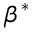Convert formula to latex. <formula><loc_0><loc_0><loc_500><loc_500>\beta ^ { * }</formula> 